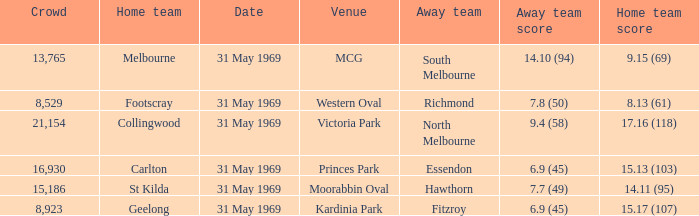What was the greatest number of people in victoria park? 21154.0. 